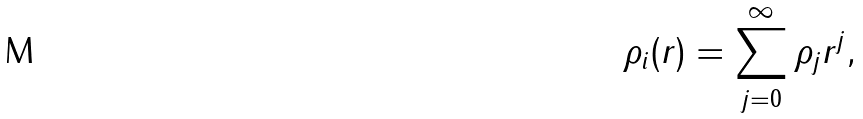Convert formula to latex. <formula><loc_0><loc_0><loc_500><loc_500>\rho _ { i } ( r ) = \sum _ { j = 0 } ^ { \infty } \rho _ { j } r ^ { j } ,</formula> 